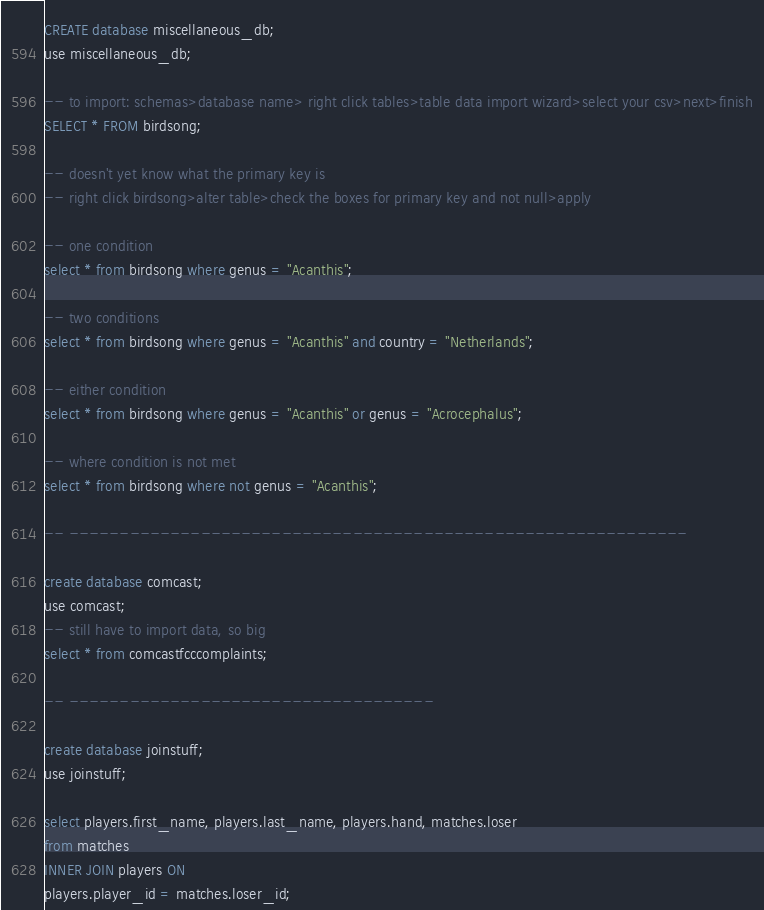Convert code to text. <code><loc_0><loc_0><loc_500><loc_500><_SQL_>CREATE database miscellaneous_db;
use miscellaneous_db;

-- to import: schemas>database name> right click tables>table data import wizard>select your csv>next>finish
SELECT * FROM birdsong;

-- doesn't yet know what the primary key is
-- right click birdsong>alter table>check the boxes for primary key and not null>apply

-- one condition
select * from birdsong where genus = "Acanthis";

-- two conditions
select * from birdsong where genus = "Acanthis" and country = "Netherlands";

-- either condition
select * from birdsong where genus = "Acanthis" or genus = "Acrocephalus";

-- where condition is not met
select * from birdsong where not genus = "Acanthis";

-- -------------------------------------------------------------

create database comcast;
use comcast;
-- still have to import data, so big
select * from comcastfcccomplaints;

-- ------------------------------------

create database joinstuff;
use joinstuff;

select players.first_name, players.last_name, players.hand, matches.loser
from matches
INNER JOIN players ON 
players.player_id = matches.loser_id;</code> 